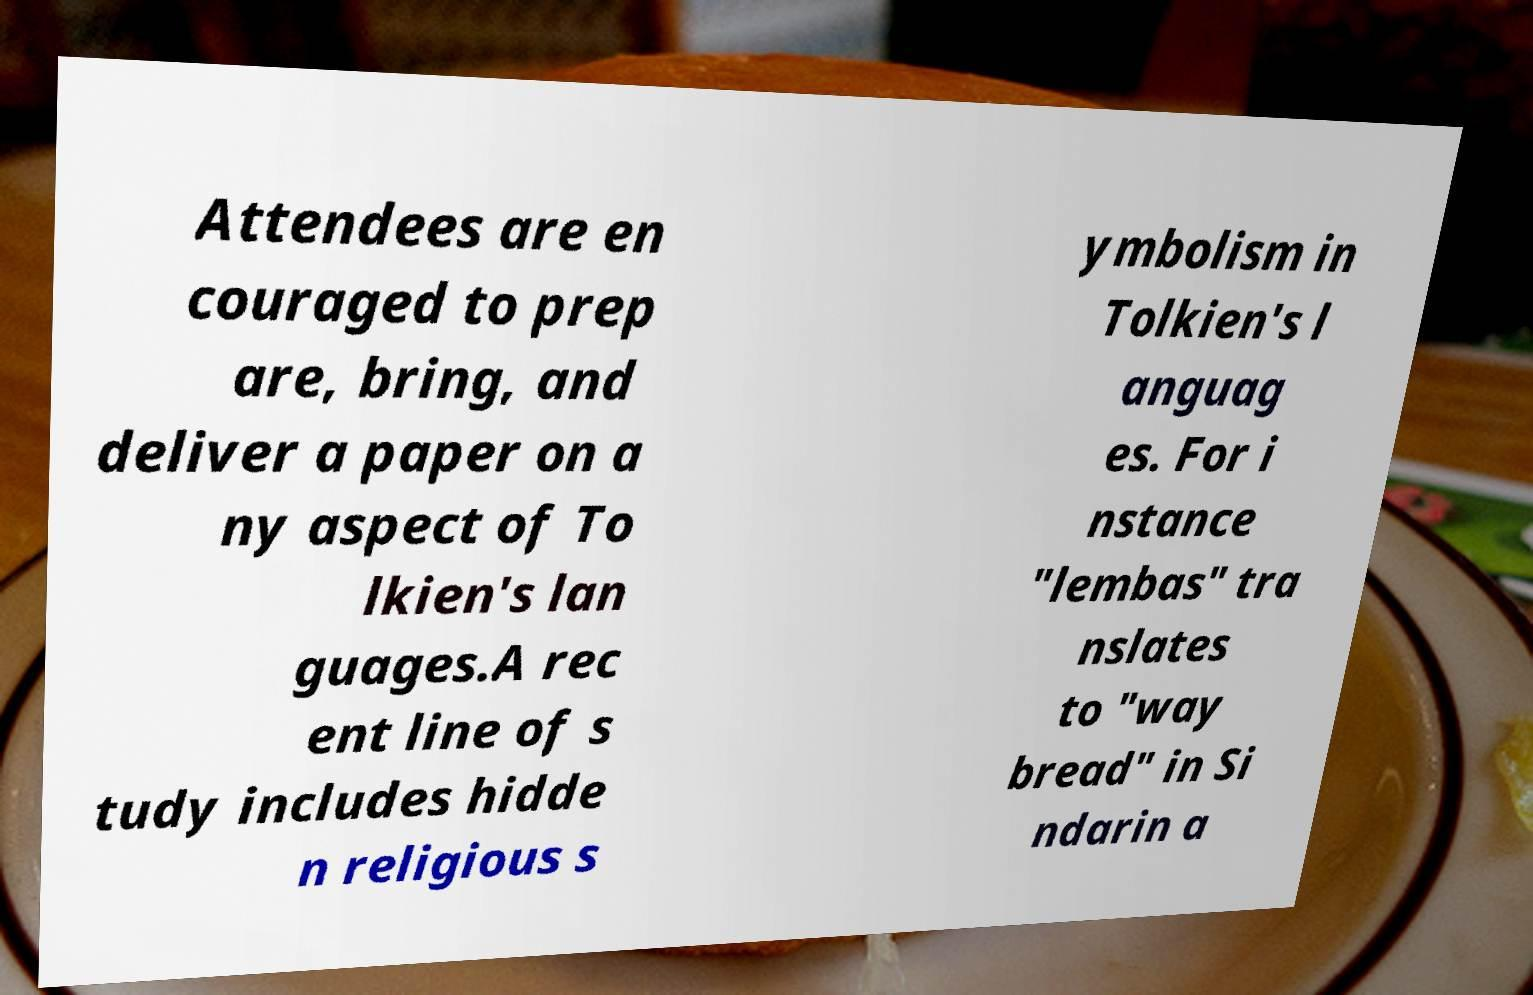Please identify and transcribe the text found in this image. Attendees are en couraged to prep are, bring, and deliver a paper on a ny aspect of To lkien's lan guages.A rec ent line of s tudy includes hidde n religious s ymbolism in Tolkien's l anguag es. For i nstance "lembas" tra nslates to "way bread" in Si ndarin a 